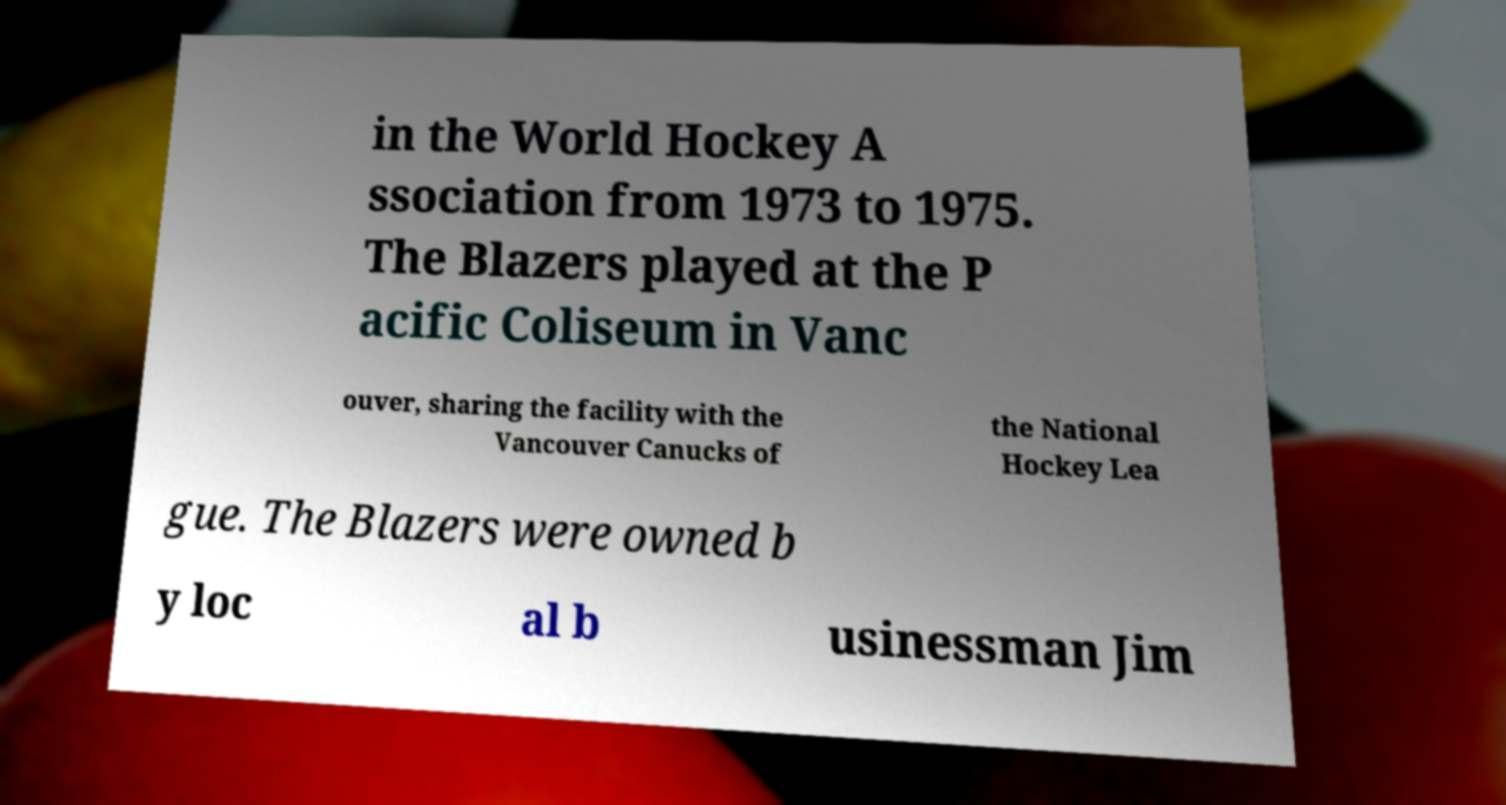Please identify and transcribe the text found in this image. in the World Hockey A ssociation from 1973 to 1975. The Blazers played at the P acific Coliseum in Vanc ouver, sharing the facility with the Vancouver Canucks of the National Hockey Lea gue. The Blazers were owned b y loc al b usinessman Jim 